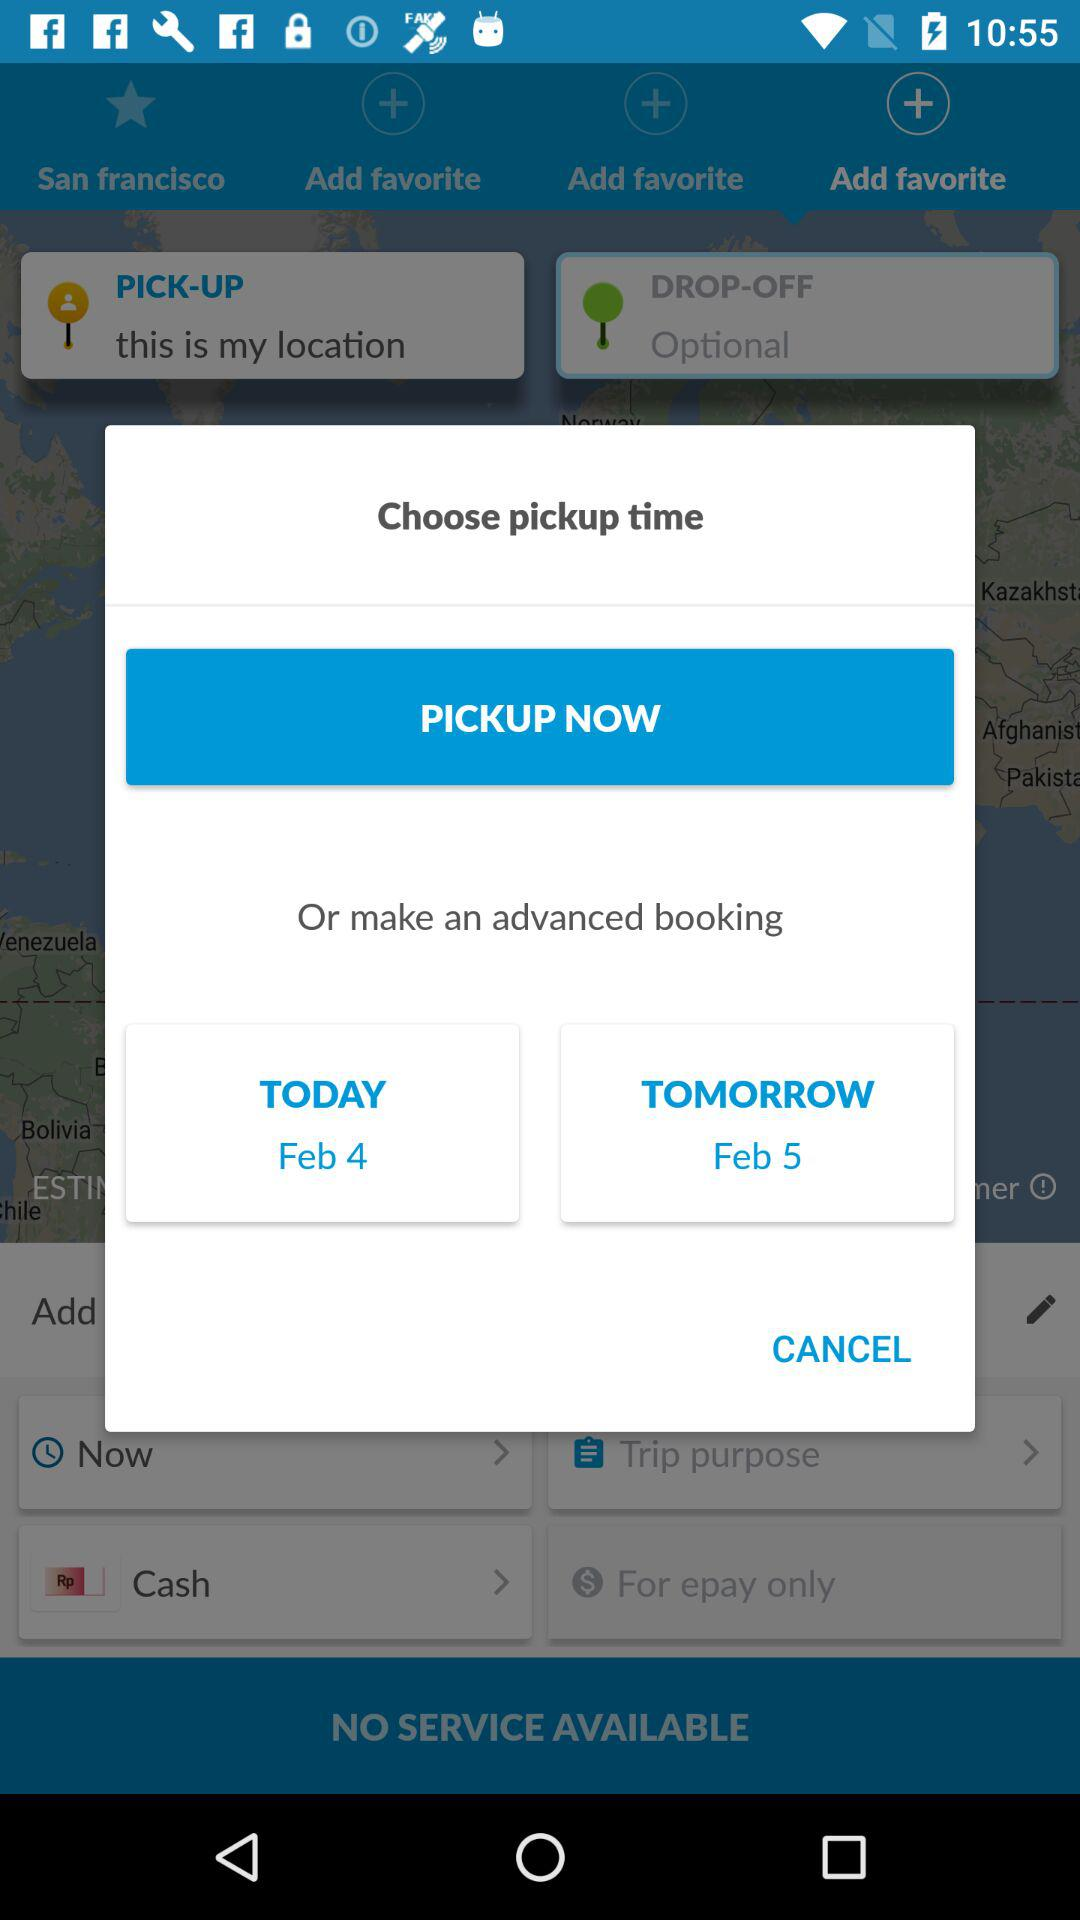What is tomorrow's shown date? Tomorrow's shown date is February 5. 